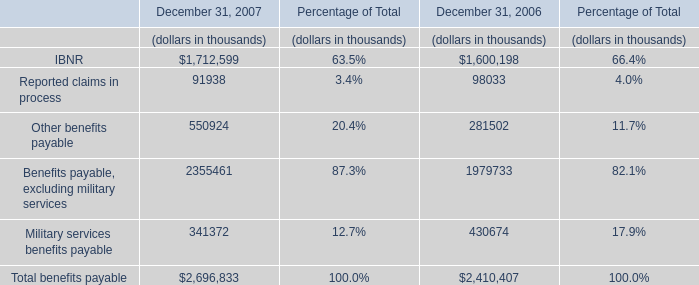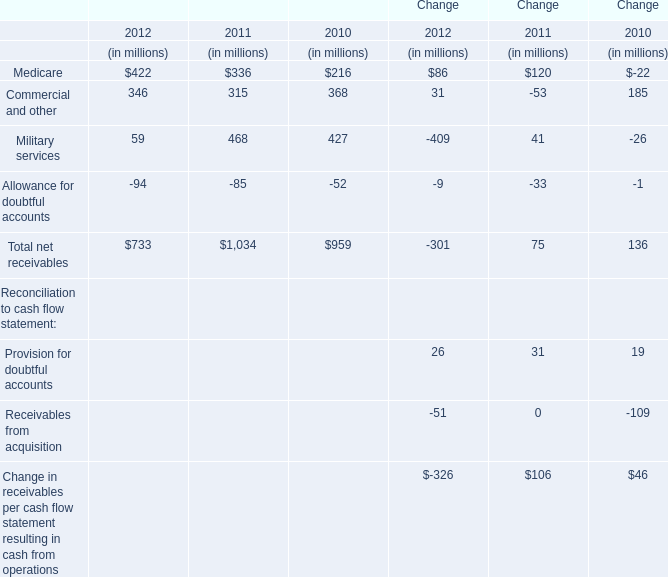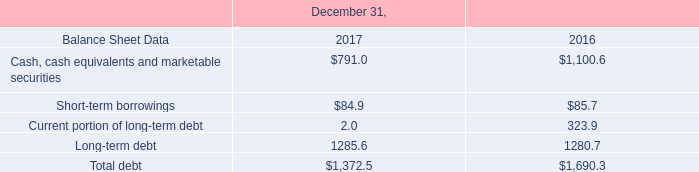What was the total amount of Change greater than 0 in 2012 ? (in million) 
Computations: ((86 + 31) + 26)
Answer: 143.0. 